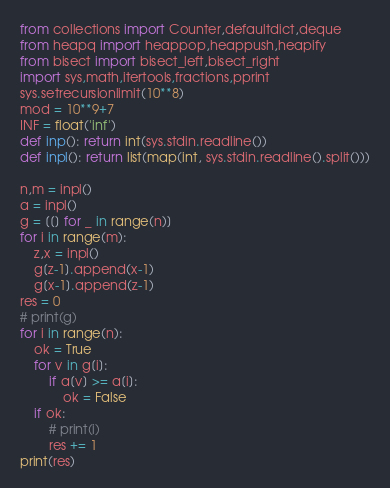<code> <loc_0><loc_0><loc_500><loc_500><_Python_>from collections import Counter,defaultdict,deque
from heapq import heappop,heappush,heapify
from bisect import bisect_left,bisect_right 
import sys,math,itertools,fractions,pprint
sys.setrecursionlimit(10**8)
mod = 10**9+7
INF = float('inf')
def inp(): return int(sys.stdin.readline())
def inpl(): return list(map(int, sys.stdin.readline().split()))

n,m = inpl()
a = inpl()
g = [[] for _ in range(n)]
for i in range(m):
    z,x = inpl()
    g[z-1].append(x-1)
    g[x-1].append(z-1)
res = 0
# print(g)
for i in range(n):
    ok = True
    for v in g[i]:
        if a[v] >= a[i]:
            ok = False
    if ok:
        # print(i)
        res += 1
print(res)</code> 